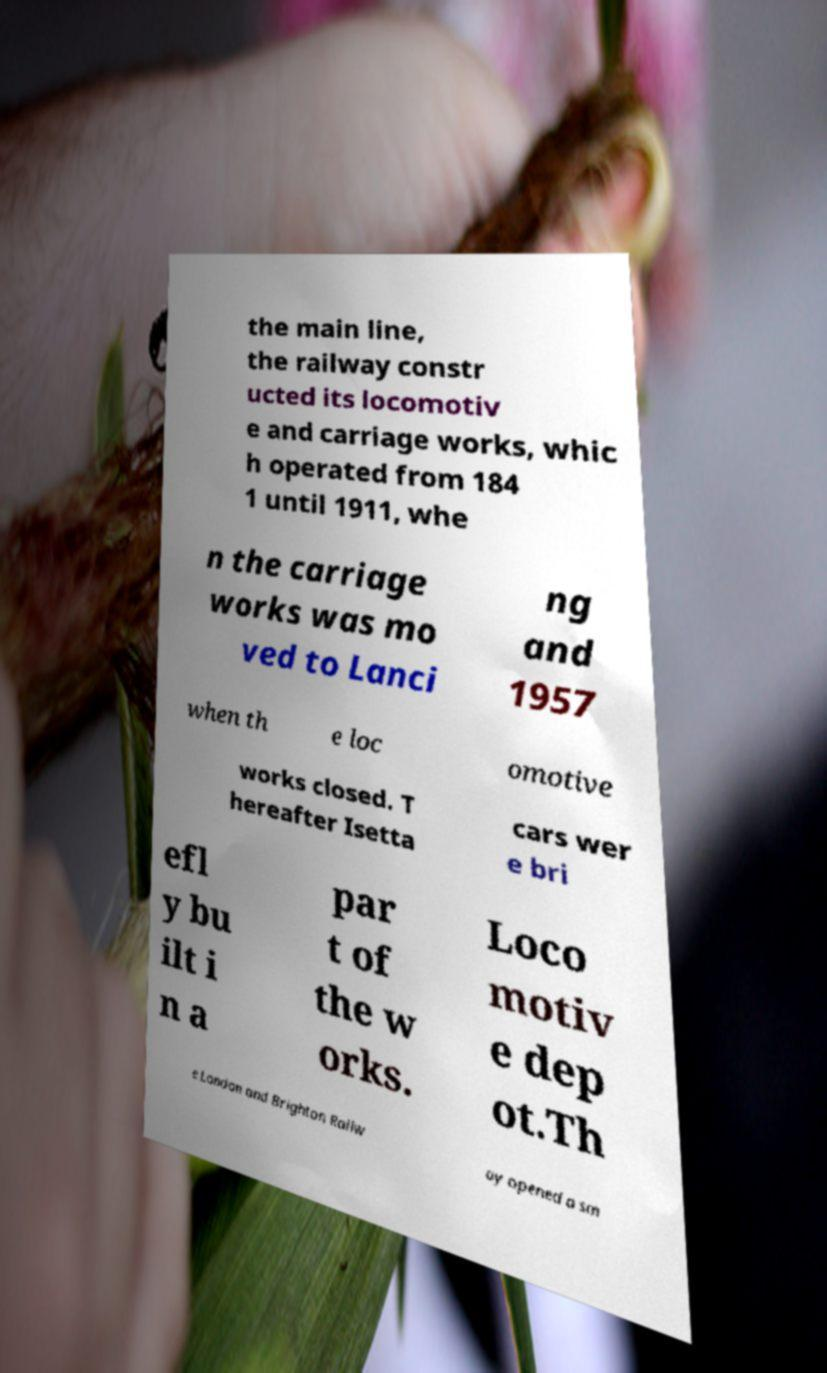For documentation purposes, I need the text within this image transcribed. Could you provide that? the main line, the railway constr ucted its locomotiv e and carriage works, whic h operated from 184 1 until 1911, whe n the carriage works was mo ved to Lanci ng and 1957 when th e loc omotive works closed. T hereafter Isetta cars wer e bri efl y bu ilt i n a par t of the w orks. Loco motiv e dep ot.Th e London and Brighton Railw ay opened a sm 